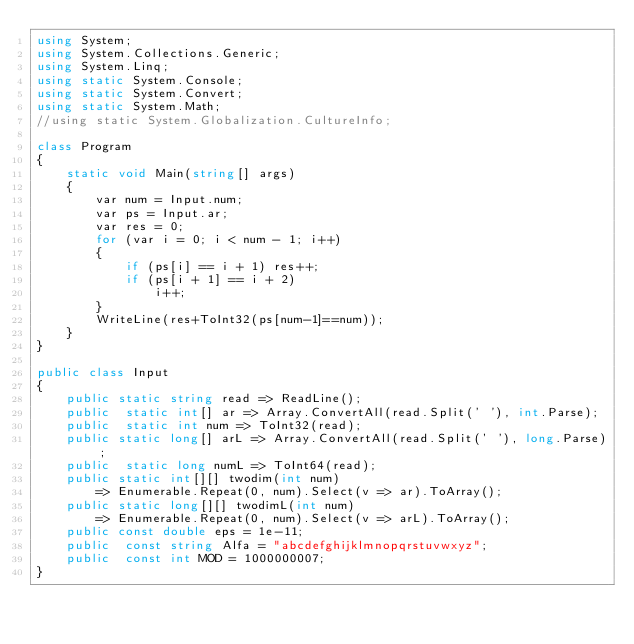Convert code to text. <code><loc_0><loc_0><loc_500><loc_500><_C#_>using System;
using System.Collections.Generic;
using System.Linq;
using static System.Console;
using static System.Convert;
using static System.Math;
//using static System.Globalization.CultureInfo;

class Program
{
    static void Main(string[] args)
    {
        var num = Input.num;
        var ps = Input.ar;
        var res = 0;
        for (var i = 0; i < num - 1; i++)
        {
            if (ps[i] == i + 1) res++;
            if (ps[i + 1] == i + 2)
                i++;
        }
        WriteLine(res+ToInt32(ps[num-1]==num));
    }
}

public class Input
{
    public static string read => ReadLine();
    public  static int[] ar => Array.ConvertAll(read.Split(' '), int.Parse);
    public  static int num => ToInt32(read);
    public static long[] arL => Array.ConvertAll(read.Split(' '), long.Parse);
    public  static long numL => ToInt64(read);
    public static int[][] twodim(int num)
        => Enumerable.Repeat(0, num).Select(v => ar).ToArray();
    public static long[][] twodimL(int num)
        => Enumerable.Repeat(0, num).Select(v => arL).ToArray();
    public const double eps = 1e-11;
    public  const string Alfa = "abcdefghijklmnopqrstuvwxyz";
    public  const int MOD = 1000000007;
}
</code> 